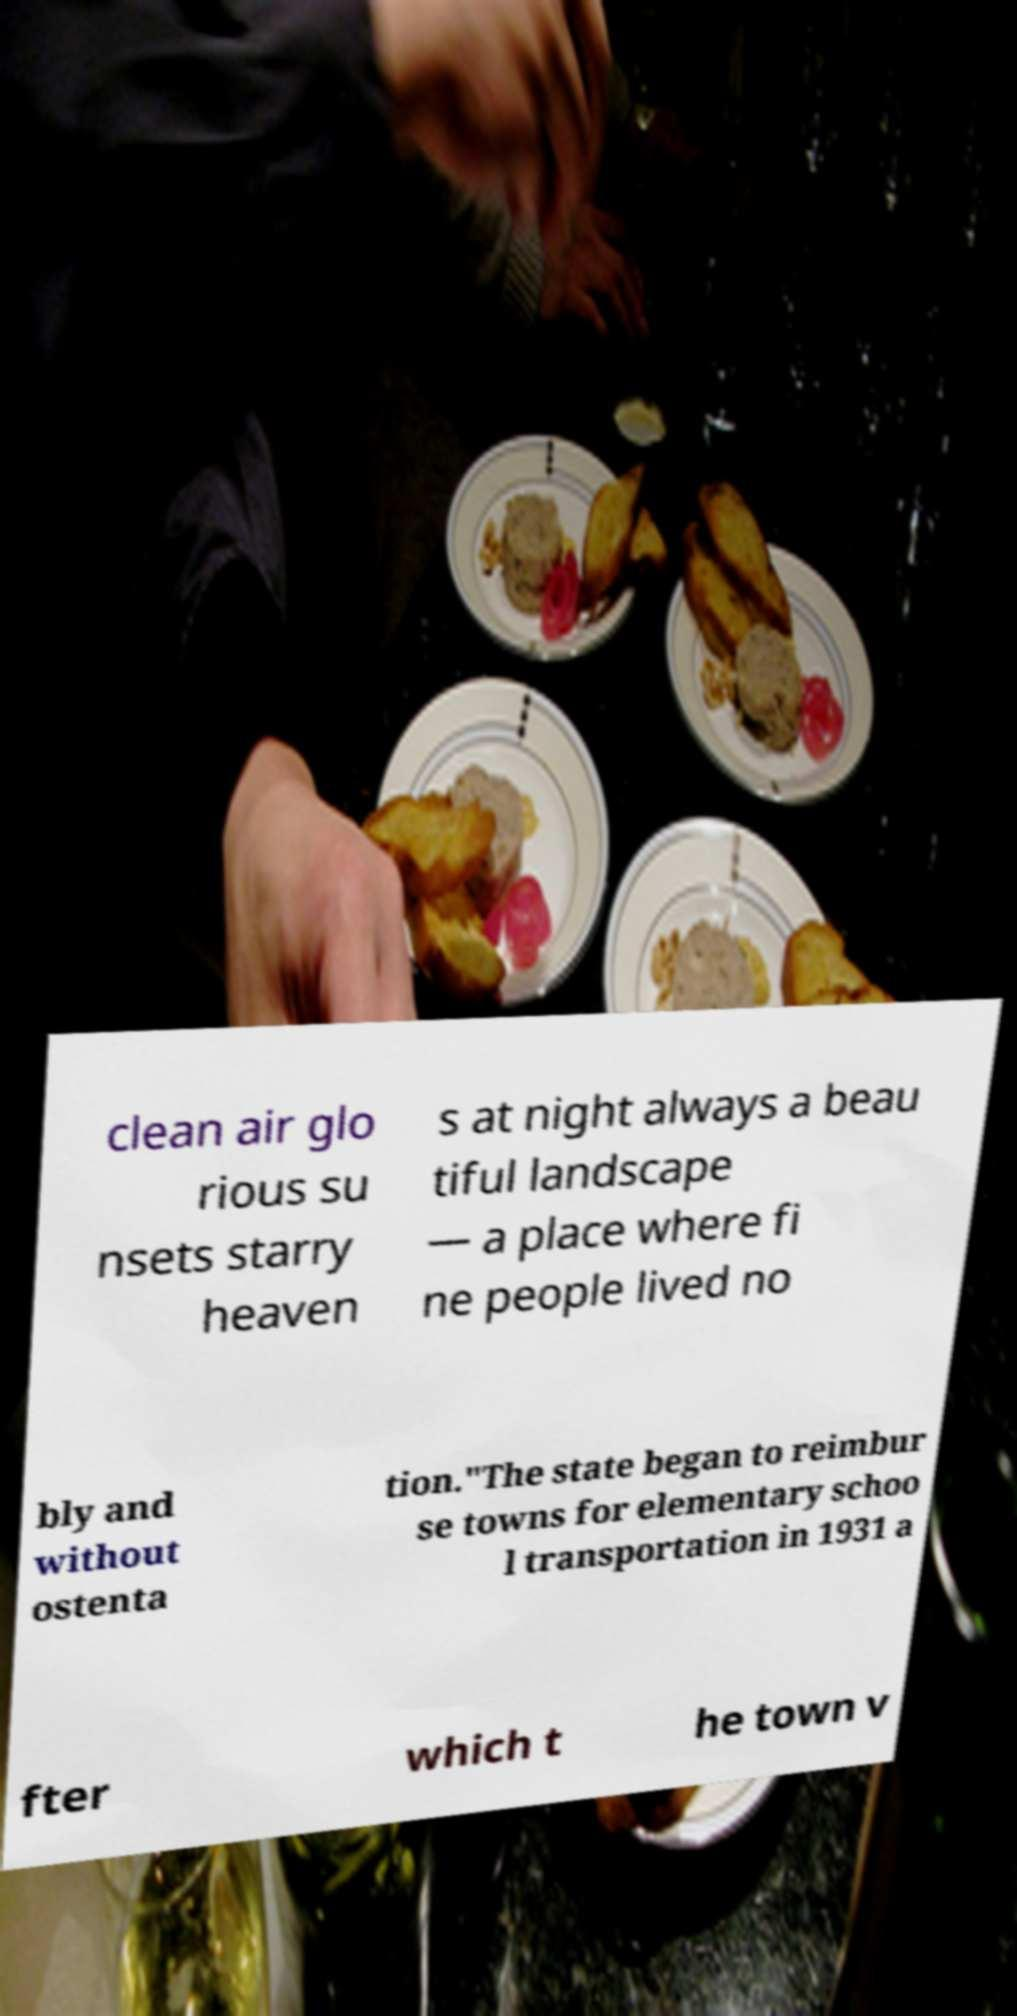Please identify and transcribe the text found in this image. clean air glo rious su nsets starry heaven s at night always a beau tiful landscape — a place where fi ne people lived no bly and without ostenta tion."The state began to reimbur se towns for elementary schoo l transportation in 1931 a fter which t he town v 